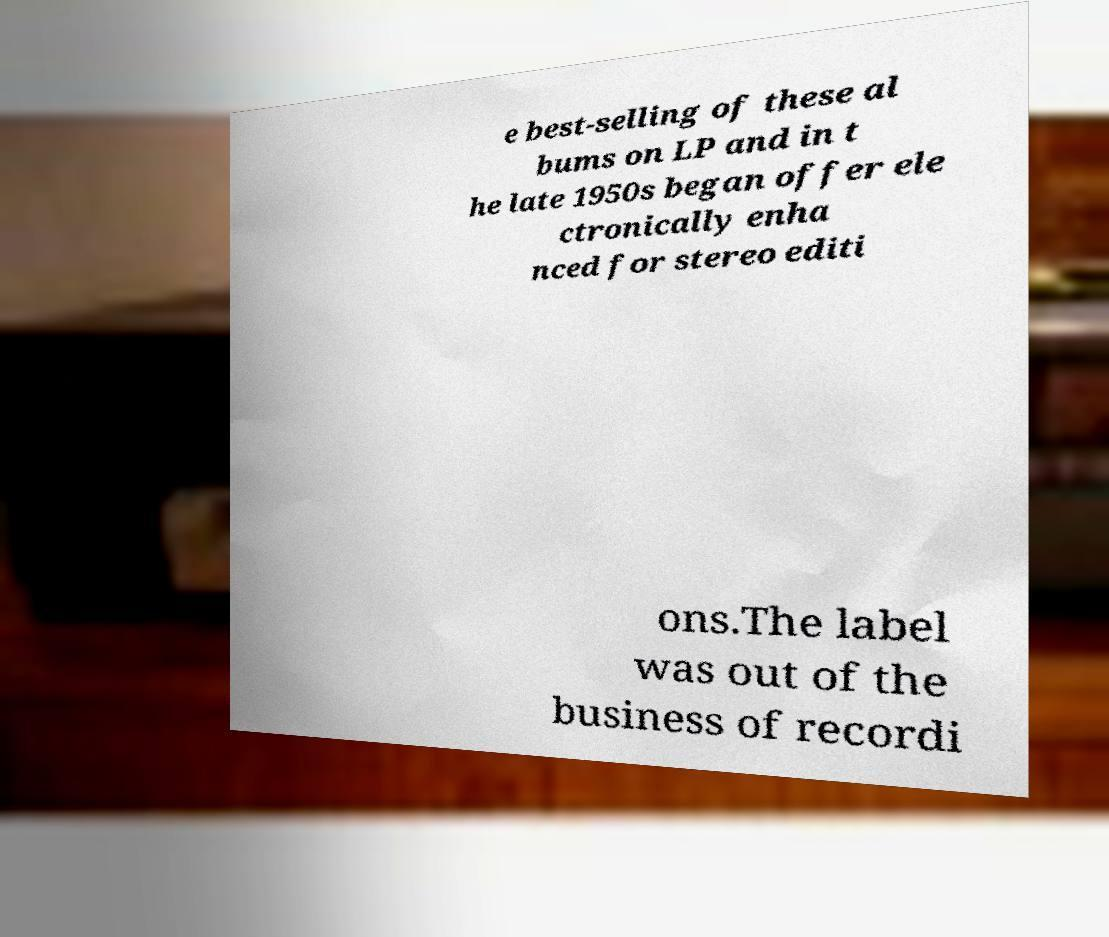Please read and relay the text visible in this image. What does it say? e best-selling of these al bums on LP and in t he late 1950s began offer ele ctronically enha nced for stereo editi ons.The label was out of the business of recordi 